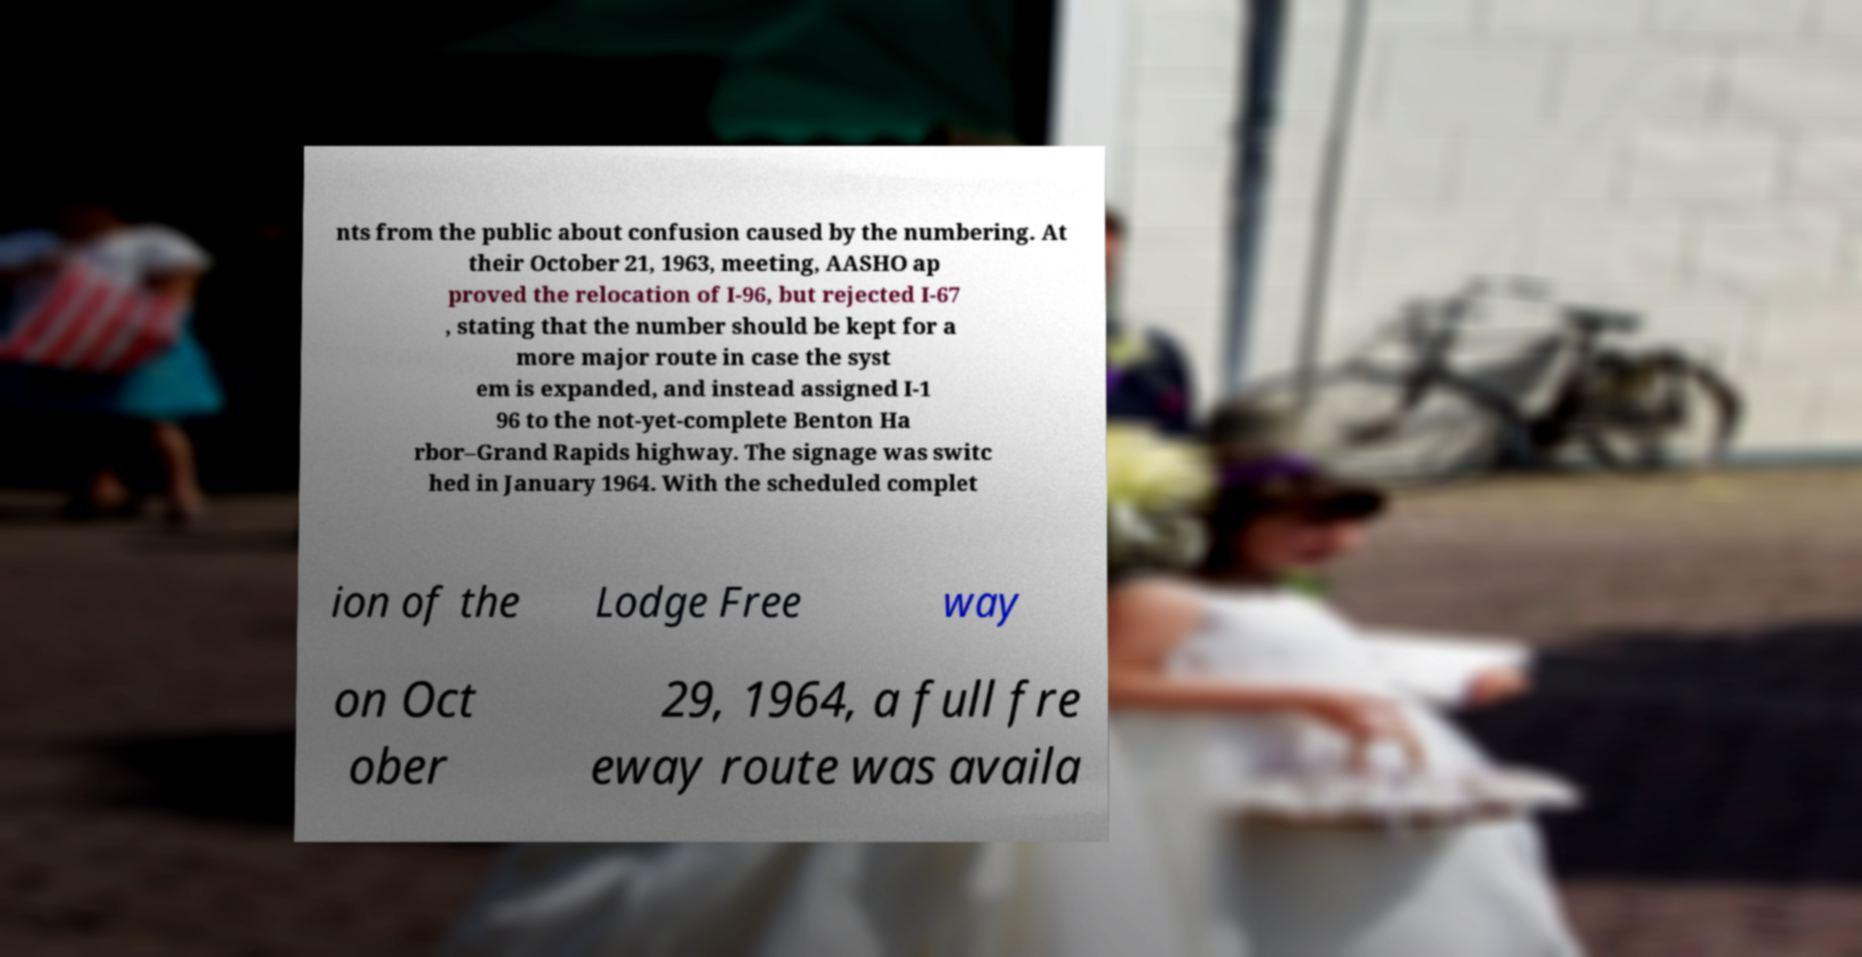I need the written content from this picture converted into text. Can you do that? nts from the public about confusion caused by the numbering. At their October 21, 1963, meeting, AASHO ap proved the relocation of I-96, but rejected I-67 , stating that the number should be kept for a more major route in case the syst em is expanded, and instead assigned I-1 96 to the not-yet-complete Benton Ha rbor–Grand Rapids highway. The signage was switc hed in January 1964. With the scheduled complet ion of the Lodge Free way on Oct ober 29, 1964, a full fre eway route was availa 